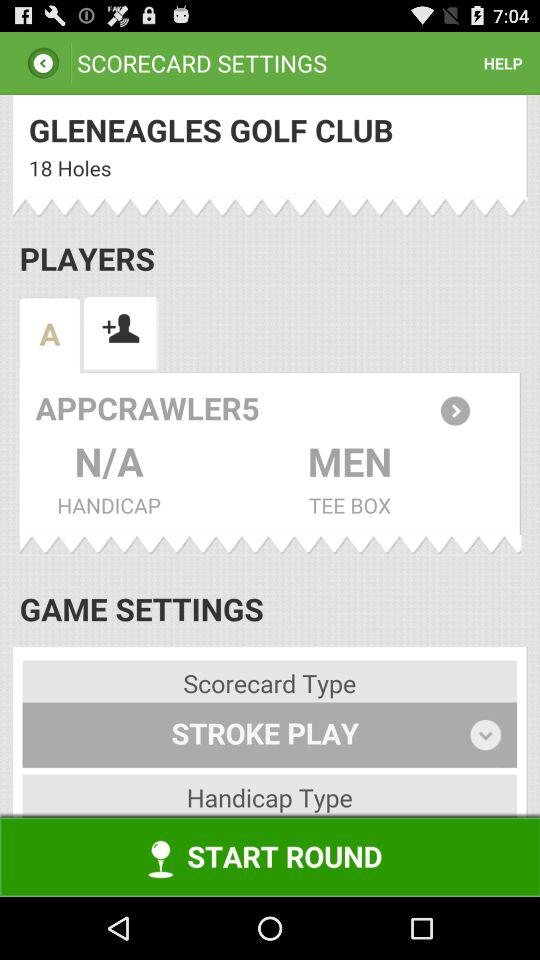What is the name of the club? The name of the club is "GLENEAGLES GOLF CLUB". 